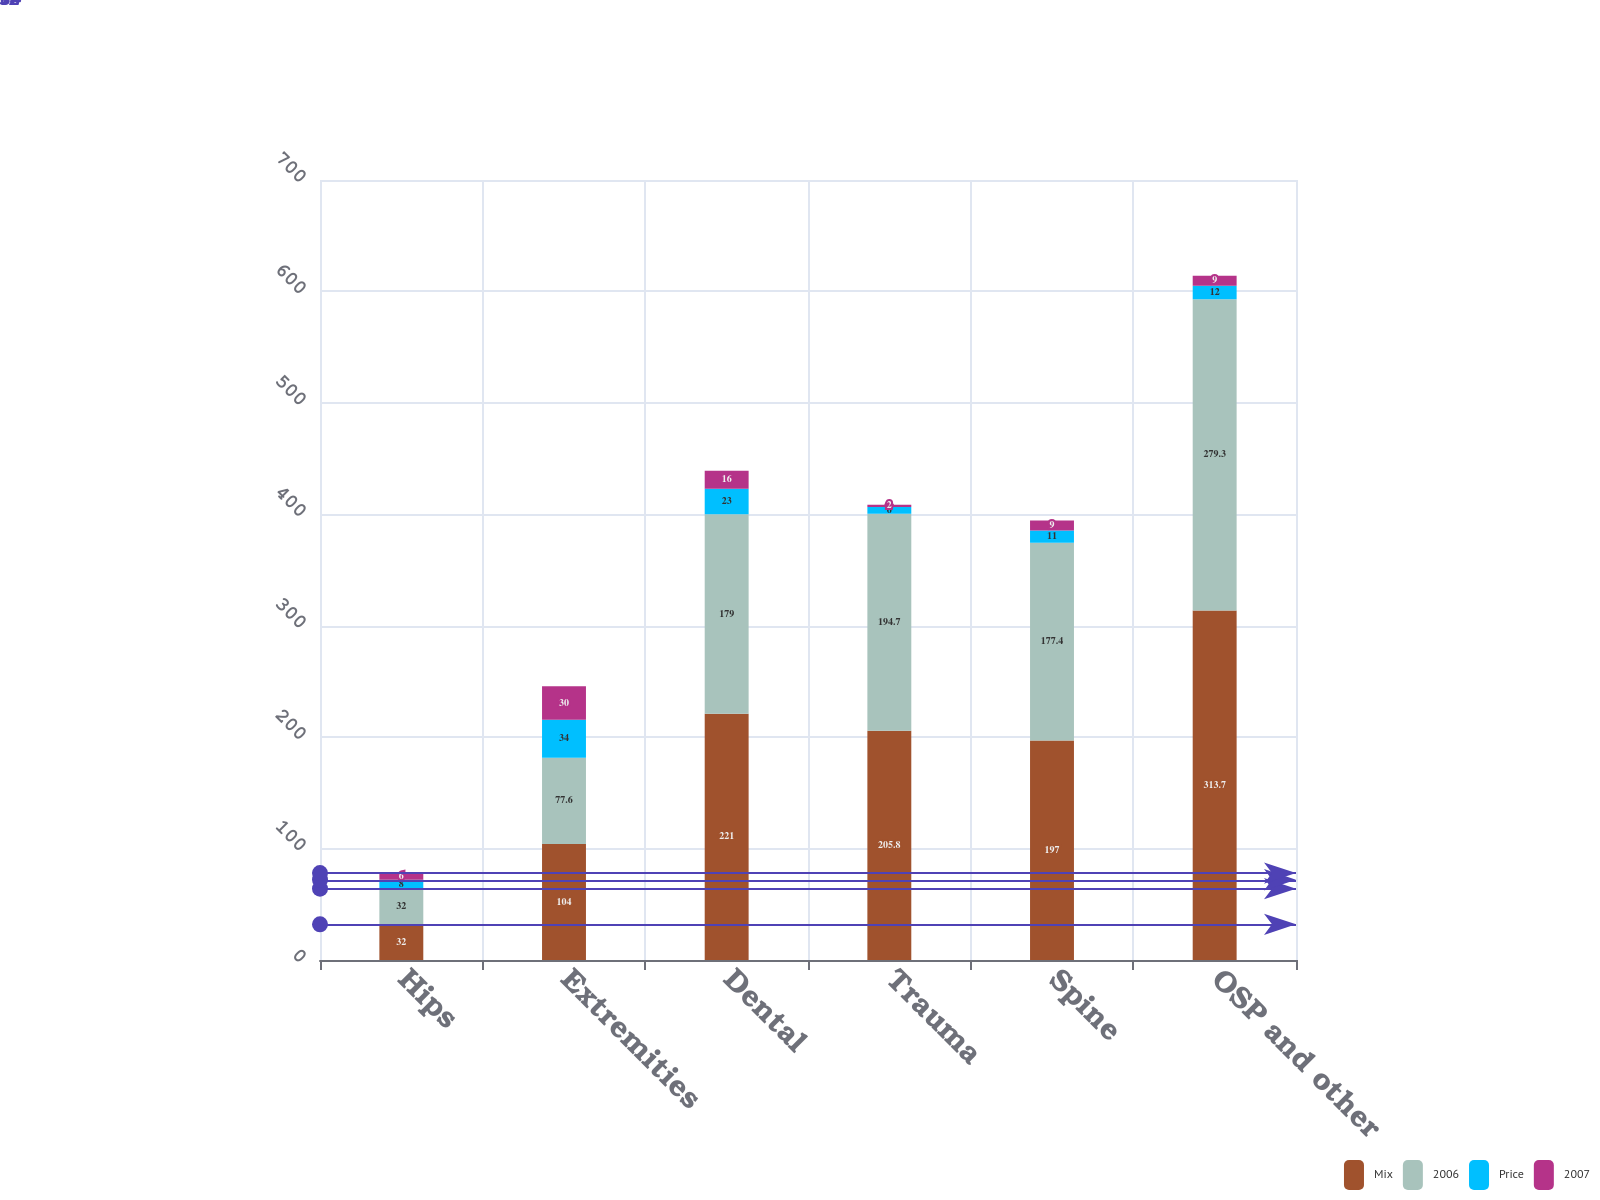Convert chart. <chart><loc_0><loc_0><loc_500><loc_500><stacked_bar_chart><ecel><fcel>Hips<fcel>Extremities<fcel>Dental<fcel>Trauma<fcel>Spine<fcel>OSP and other<nl><fcel>Mix<fcel>32<fcel>104<fcel>221<fcel>205.8<fcel>197<fcel>313.7<nl><fcel>2006<fcel>32<fcel>77.6<fcel>179<fcel>194.7<fcel>177.4<fcel>279.3<nl><fcel>Price<fcel>8<fcel>34<fcel>23<fcel>6<fcel>11<fcel>12<nl><fcel>2007<fcel>6<fcel>30<fcel>16<fcel>2<fcel>9<fcel>9<nl></chart> 